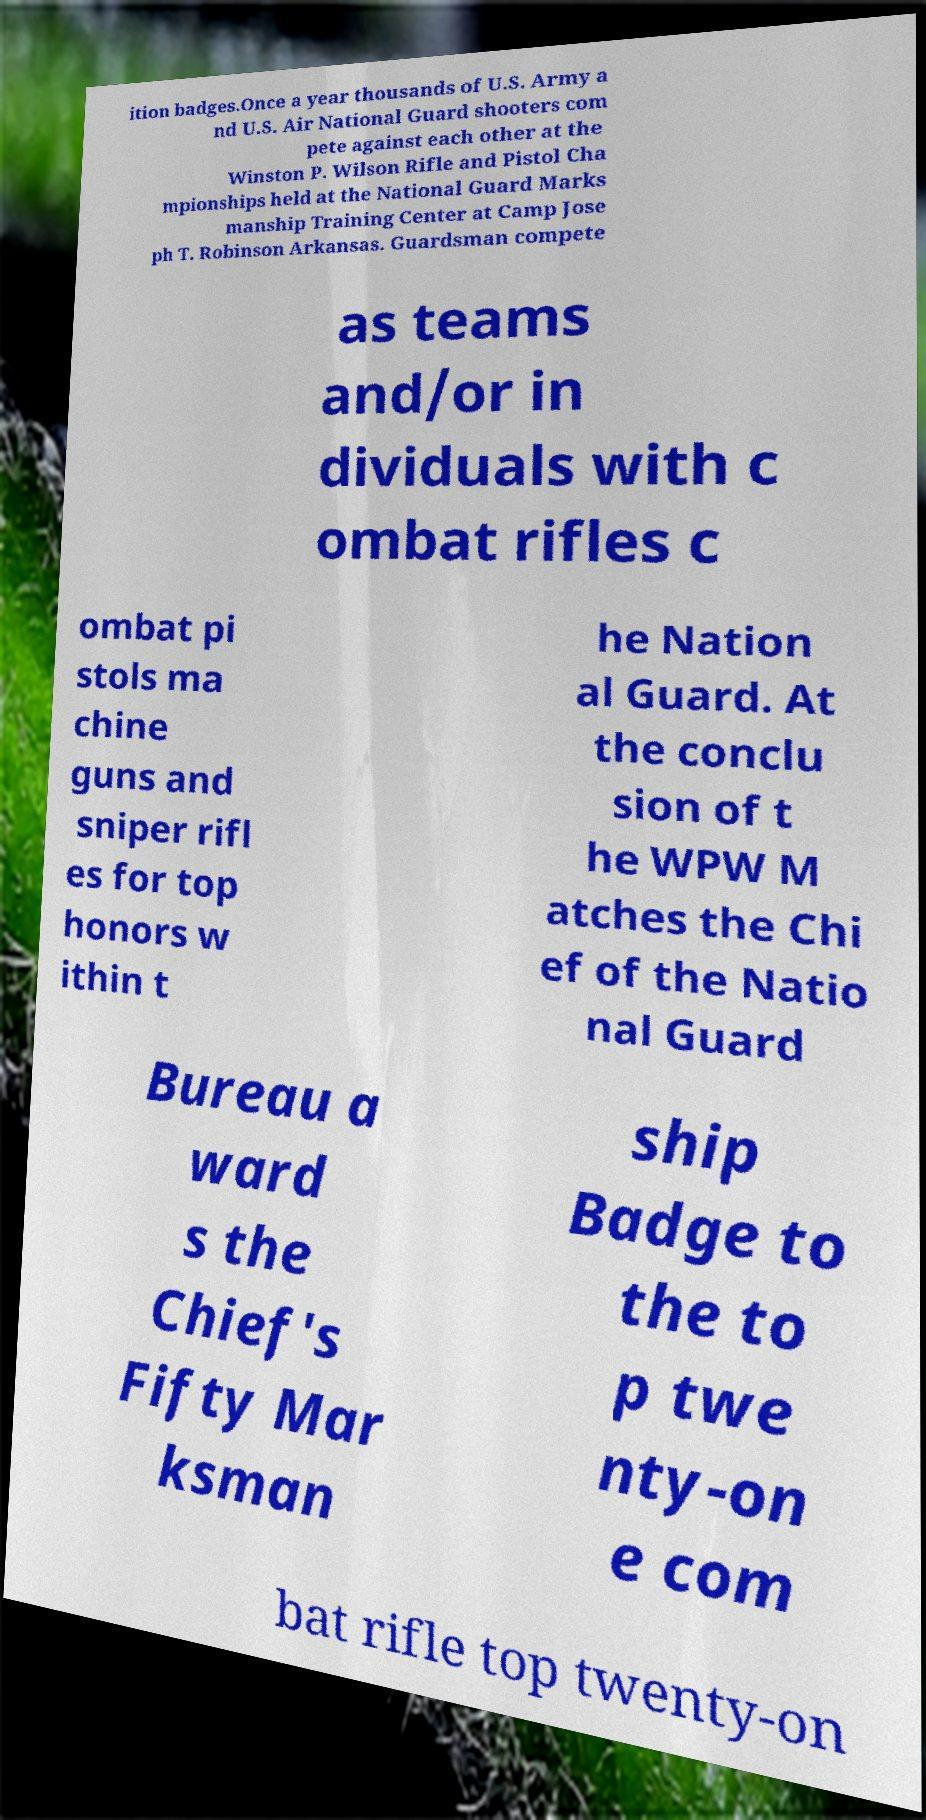Can you read and provide the text displayed in the image?This photo seems to have some interesting text. Can you extract and type it out for me? ition badges.Once a year thousands of U.S. Army a nd U.S. Air National Guard shooters com pete against each other at the Winston P. Wilson Rifle and Pistol Cha mpionships held at the National Guard Marks manship Training Center at Camp Jose ph T. Robinson Arkansas. Guardsman compete as teams and/or in dividuals with c ombat rifles c ombat pi stols ma chine guns and sniper rifl es for top honors w ithin t he Nation al Guard. At the conclu sion of t he WPW M atches the Chi ef of the Natio nal Guard Bureau a ward s the Chief's Fifty Mar ksman ship Badge to the to p twe nty-on e com bat rifle top twenty-on 